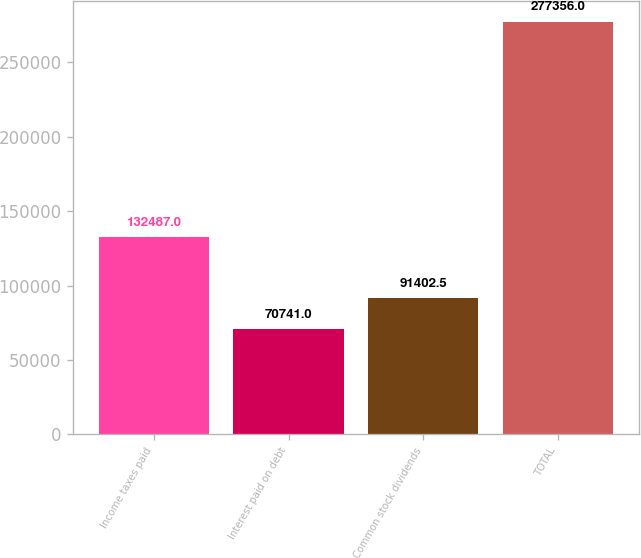Convert chart to OTSL. <chart><loc_0><loc_0><loc_500><loc_500><bar_chart><fcel>Income taxes paid<fcel>Interest paid on debt<fcel>Common stock dividends<fcel>TOTAL<nl><fcel>132487<fcel>70741<fcel>91402.5<fcel>277356<nl></chart> 